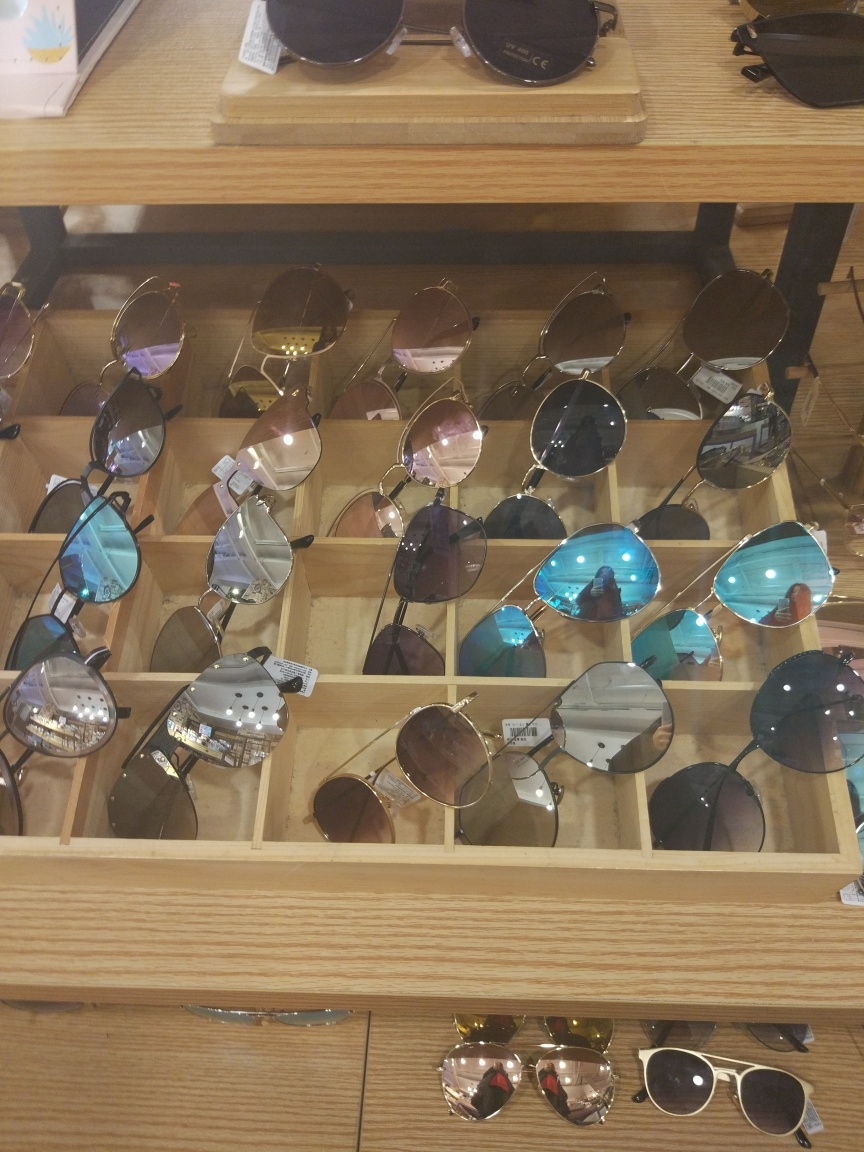How many pairs of sunglasses can you see here? There appear to be at least two dozen pairs of sunglasses presented across several rows and columns in the display. Are they arranged in any particular order or pattern? The sunglasses seem to be casually arranged with no strict pattern, with various styles and colors displayed next to each other. This arrangement allows customers to compare different models easily. 